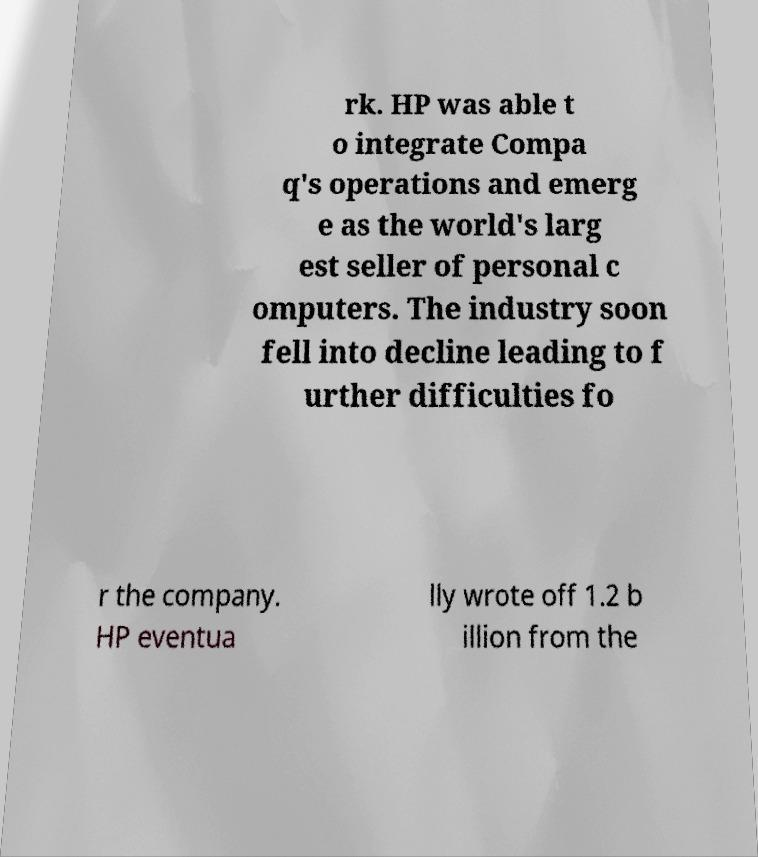Could you extract and type out the text from this image? rk. HP was able t o integrate Compa q's operations and emerg e as the world's larg est seller of personal c omputers. The industry soon fell into decline leading to f urther difficulties fo r the company. HP eventua lly wrote off 1.2 b illion from the 